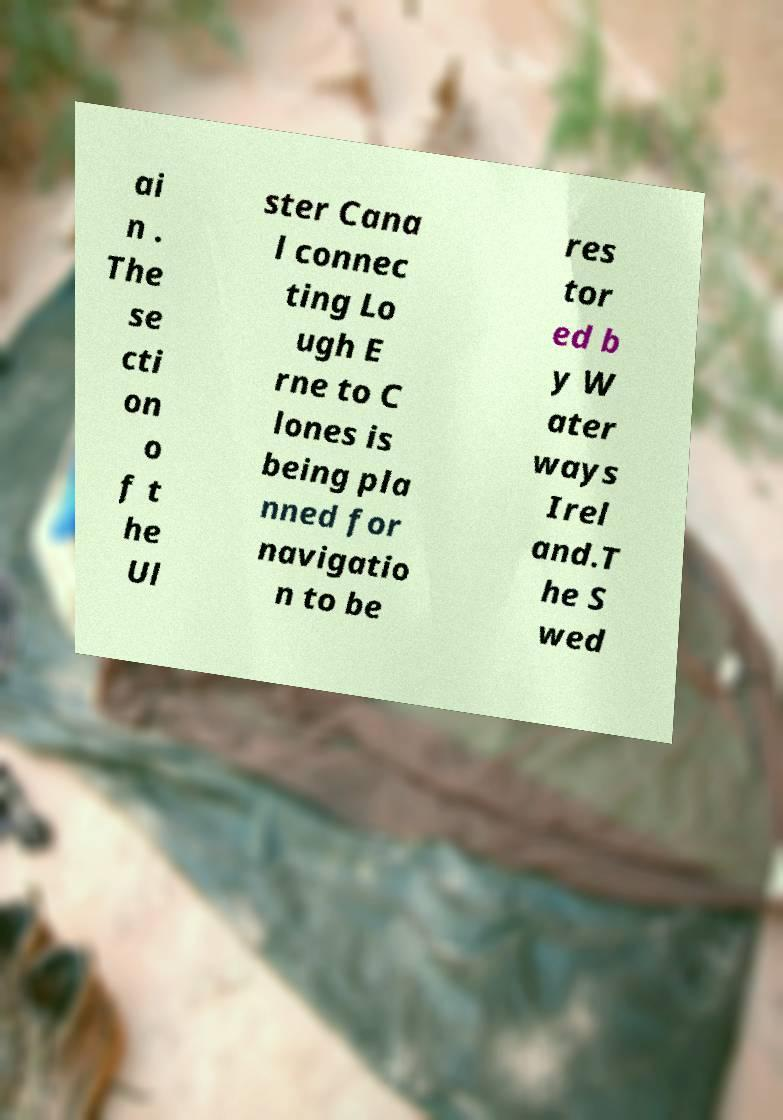For documentation purposes, I need the text within this image transcribed. Could you provide that? ai n . The se cti on o f t he Ul ster Cana l connec ting Lo ugh E rne to C lones is being pla nned for navigatio n to be res tor ed b y W ater ways Irel and.T he S wed 